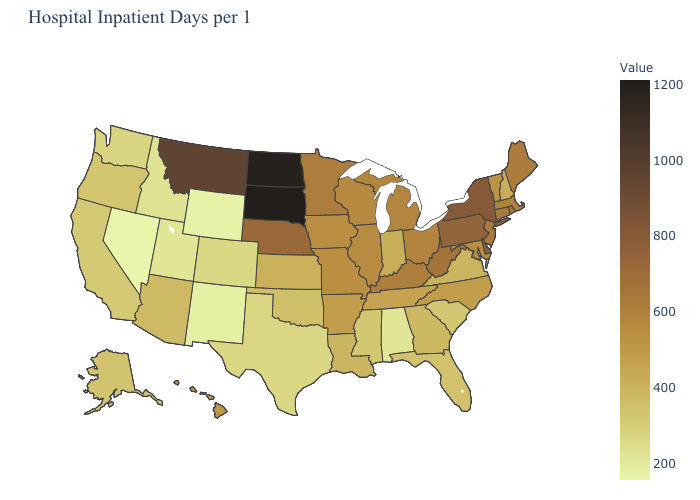Which states have the highest value in the USA?
Quick response, please. South Dakota. Does South Dakota have the highest value in the MidWest?
Write a very short answer. Yes. Among the states that border Washington , which have the lowest value?
Write a very short answer. Idaho. Among the states that border Missouri , which have the highest value?
Keep it brief. Nebraska. Does South Dakota have the lowest value in the USA?
Be succinct. No. Among the states that border Washington , which have the lowest value?
Short answer required. Idaho. Among the states that border North Carolina , which have the lowest value?
Give a very brief answer. South Carolina. Is the legend a continuous bar?
Answer briefly. Yes. Among the states that border Alabama , does Mississippi have the lowest value?
Give a very brief answer. Yes. 